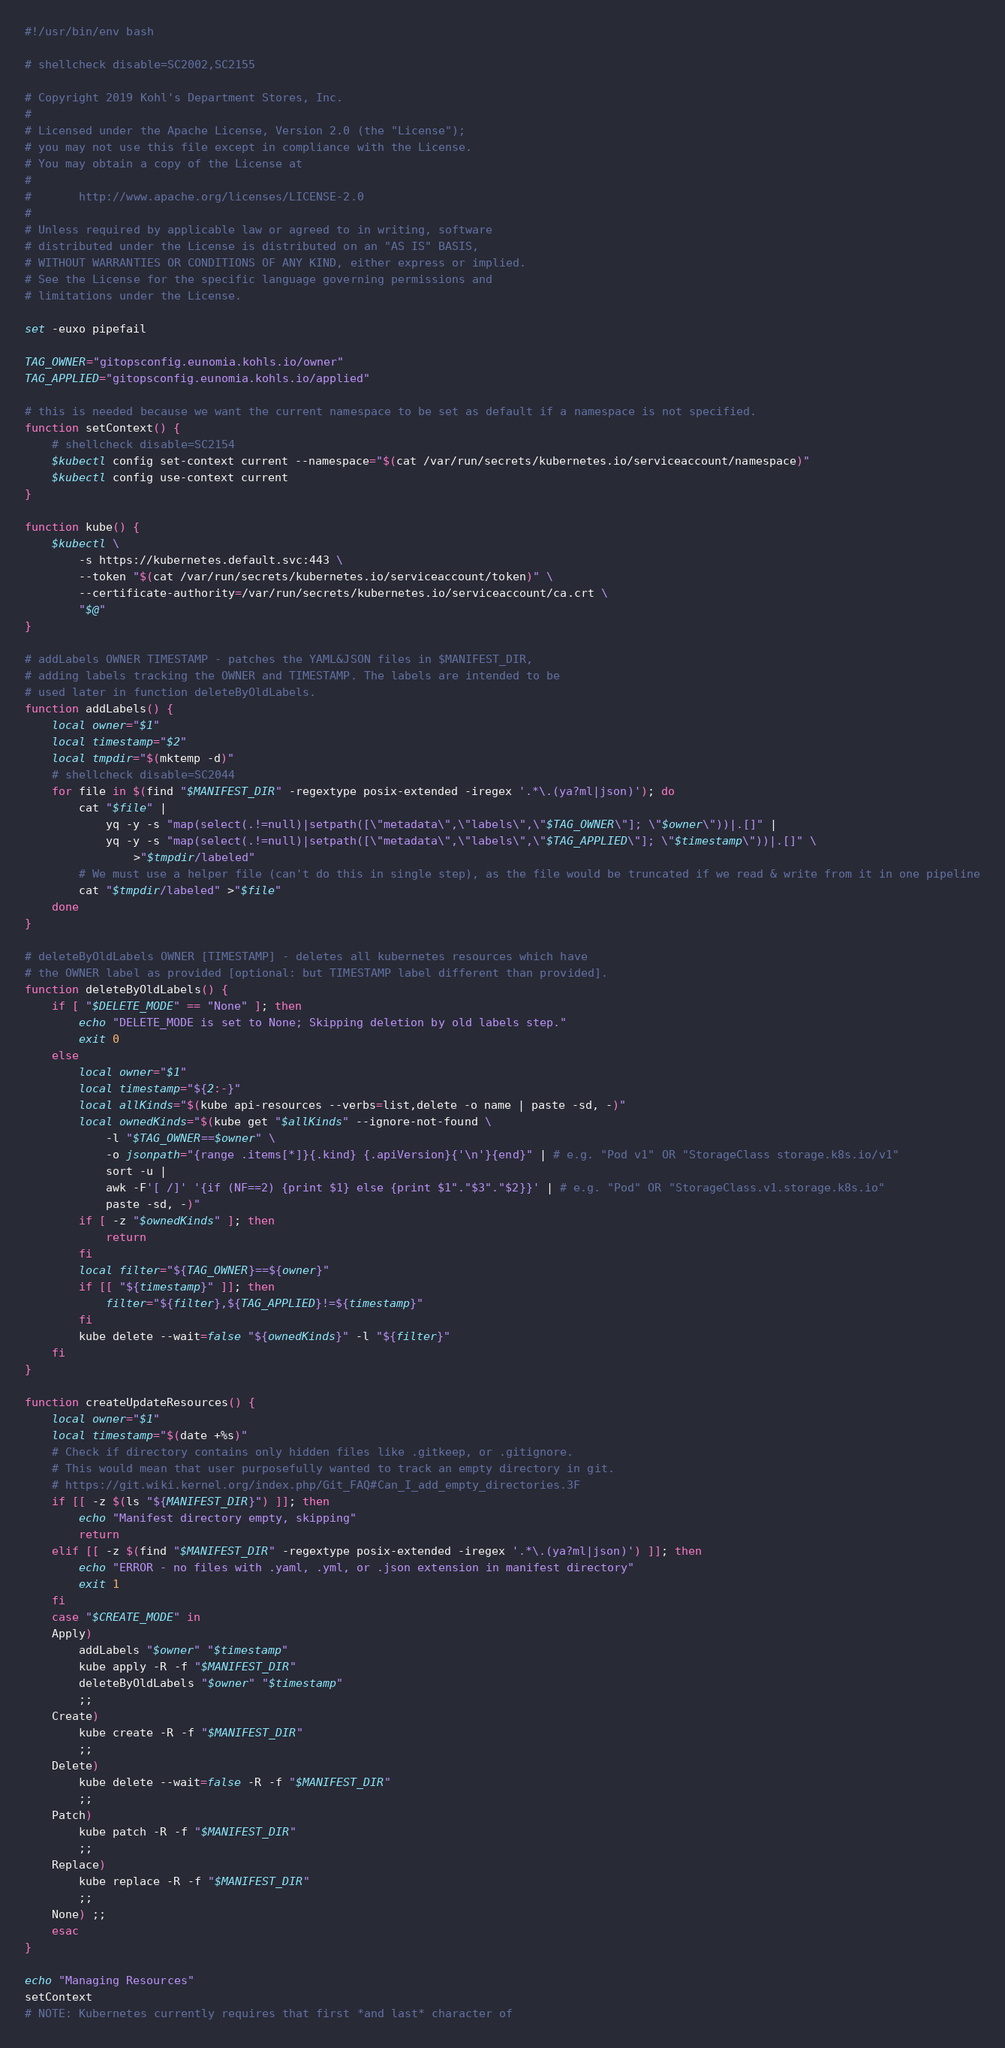<code> <loc_0><loc_0><loc_500><loc_500><_Bash_>#!/usr/bin/env bash

# shellcheck disable=SC2002,SC2155

# Copyright 2019 Kohl's Department Stores, Inc.
#
# Licensed under the Apache License, Version 2.0 (the "License");
# you may not use this file except in compliance with the License.
# You may obtain a copy of the License at
#
#       http://www.apache.org/licenses/LICENSE-2.0
#
# Unless required by applicable law or agreed to in writing, software
# distributed under the License is distributed on an "AS IS" BASIS,
# WITHOUT WARRANTIES OR CONDITIONS OF ANY KIND, either express or implied.
# See the License for the specific language governing permissions and
# limitations under the License.

set -euxo pipefail

TAG_OWNER="gitopsconfig.eunomia.kohls.io/owner"
TAG_APPLIED="gitopsconfig.eunomia.kohls.io/applied"

# this is needed because we want the current namespace to be set as default if a namespace is not specified.
function setContext() {
    # shellcheck disable=SC2154
    $kubectl config set-context current --namespace="$(cat /var/run/secrets/kubernetes.io/serviceaccount/namespace)"
    $kubectl config use-context current
}

function kube() {
    $kubectl \
        -s https://kubernetes.default.svc:443 \
        --token "$(cat /var/run/secrets/kubernetes.io/serviceaccount/token)" \
        --certificate-authority=/var/run/secrets/kubernetes.io/serviceaccount/ca.crt \
        "$@"
}

# addLabels OWNER TIMESTAMP - patches the YAML&JSON files in $MANIFEST_DIR,
# adding labels tracking the OWNER and TIMESTAMP. The labels are intended to be
# used later in function deleteByOldLabels.
function addLabels() {
    local owner="$1"
    local timestamp="$2"
    local tmpdir="$(mktemp -d)"
    # shellcheck disable=SC2044
    for file in $(find "$MANIFEST_DIR" -regextype posix-extended -iregex '.*\.(ya?ml|json)'); do
        cat "$file" |
            yq -y -s "map(select(.!=null)|setpath([\"metadata\",\"labels\",\"$TAG_OWNER\"]; \"$owner\"))|.[]" |
            yq -y -s "map(select(.!=null)|setpath([\"metadata\",\"labels\",\"$TAG_APPLIED\"]; \"$timestamp\"))|.[]" \
                >"$tmpdir/labeled"
        # We must use a helper file (can't do this in single step), as the file would be truncated if we read & write from it in one pipeline
        cat "$tmpdir/labeled" >"$file"
    done
}

# deleteByOldLabels OWNER [TIMESTAMP] - deletes all kubernetes resources which have
# the OWNER label as provided [optional: but TIMESTAMP label different than provided].
function deleteByOldLabels() {
    if [ "$DELETE_MODE" == "None" ]; then
        echo "DELETE_MODE is set to None; Skipping deletion by old labels step."
        exit 0
    else
        local owner="$1"
        local timestamp="${2:-}"
        local allKinds="$(kube api-resources --verbs=list,delete -o name | paste -sd, -)"
        local ownedKinds="$(kube get "$allKinds" --ignore-not-found \
            -l "$TAG_OWNER==$owner" \
            -o jsonpath="{range .items[*]}{.kind} {.apiVersion}{'\n'}{end}" | # e.g. "Pod v1" OR "StorageClass storage.k8s.io/v1"
            sort -u |
            awk -F'[ /]' '{if (NF==2) {print $1} else {print $1"."$3"."$2}}' | # e.g. "Pod" OR "StorageClass.v1.storage.k8s.io"
            paste -sd, -)"
        if [ -z "$ownedKinds" ]; then
            return
        fi
        local filter="${TAG_OWNER}==${owner}"
        if [[ "${timestamp}" ]]; then
            filter="${filter},${TAG_APPLIED}!=${timestamp}"
        fi
        kube delete --wait=false "${ownedKinds}" -l "${filter}"
    fi
}

function createUpdateResources() {
    local owner="$1"
    local timestamp="$(date +%s)"
    # Check if directory contains only hidden files like .gitkeep, or .gitignore.
    # This would mean that user purposefully wanted to track an empty directory in git.
    # https://git.wiki.kernel.org/index.php/Git_FAQ#Can_I_add_empty_directories.3F
    if [[ -z $(ls "${MANIFEST_DIR}") ]]; then
        echo "Manifest directory empty, skipping"
        return
    elif [[ -z $(find "$MANIFEST_DIR" -regextype posix-extended -iregex '.*\.(ya?ml|json)') ]]; then
        echo "ERROR - no files with .yaml, .yml, or .json extension in manifest directory"
        exit 1
    fi
    case "$CREATE_MODE" in
    Apply)
        addLabels "$owner" "$timestamp"
        kube apply -R -f "$MANIFEST_DIR"
        deleteByOldLabels "$owner" "$timestamp"
        ;;
    Create)
        kube create -R -f "$MANIFEST_DIR"
        ;;
    Delete)
        kube delete --wait=false -R -f "$MANIFEST_DIR"
        ;;
    Patch)
        kube patch -R -f "$MANIFEST_DIR"
        ;;
    Replace)
        kube replace -R -f "$MANIFEST_DIR"
        ;;
    None) ;;
    esac
}

echo "Managing Resources"
setContext
# NOTE: Kubernetes currently requires that first *and last* character of</code> 